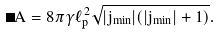<formula> <loc_0><loc_0><loc_500><loc_500>\Delta A = 8 \pi \gamma \ell _ { p } ^ { 2 } \sqrt { | j _ { \min } | ( | j _ { \min } | + 1 ) } .</formula> 